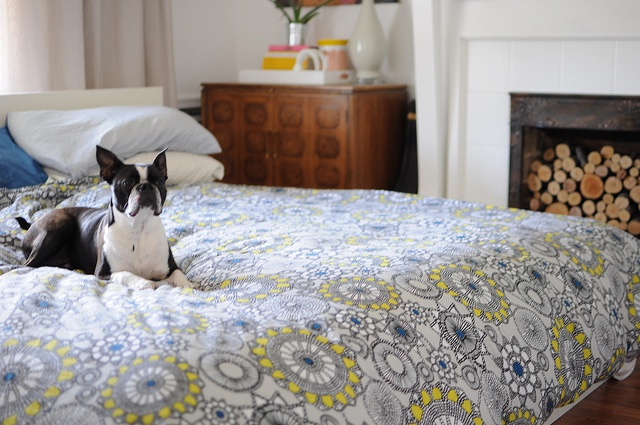Describe the objects in this image and their specific colors. I can see bed in white, darkgray, lavender, and gray tones, dog in white, black, darkgray, gray, and lightgray tones, vase in white, darkgray, gray, and lightgray tones, and vase in white, darkgray, lightgray, and gray tones in this image. 